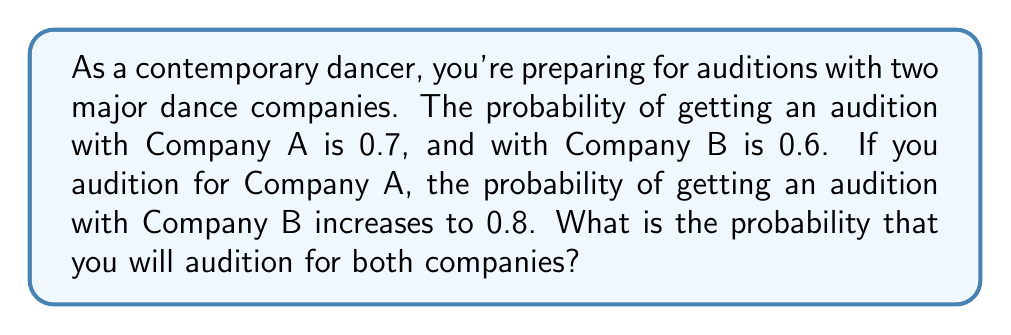Solve this math problem. Let's approach this problem using conditional probability. We'll define the following events:

A: Getting an audition with Company A
B: Getting an audition with Company B

We're given the following probabilities:

$P(A) = 0.7$
$P(B) = 0.6$
$P(B|A) = 0.8$ (probability of B given A has occurred)

To find the probability of auditioning for both companies, we need to calculate $P(A \cap B)$, which is the intersection of events A and B.

We can use the formula for conditional probability:

$$P(B|A) = \frac{P(A \cap B)}{P(A)}$$

Rearranging this formula, we get:

$$P(A \cap B) = P(B|A) \cdot P(A)$$

Now, we can substitute the known values:

$$P(A \cap B) = 0.8 \cdot 0.7 = 0.56$$

Therefore, the probability of auditioning for both companies is 0.56 or 56%.
Answer: 0.56 or 56% 